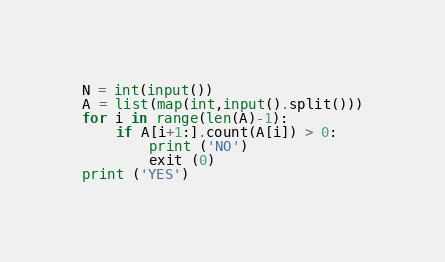<code> <loc_0><loc_0><loc_500><loc_500><_Python_>N = int(input())
A = list(map(int,input().split()))
for i in range(len(A)-1):
    if A[i+1:].count(A[i]) > 0:
        print ('NO')
        exit (0)
print ('YES')</code> 